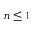<formula> <loc_0><loc_0><loc_500><loc_500>n \leq 1</formula> 